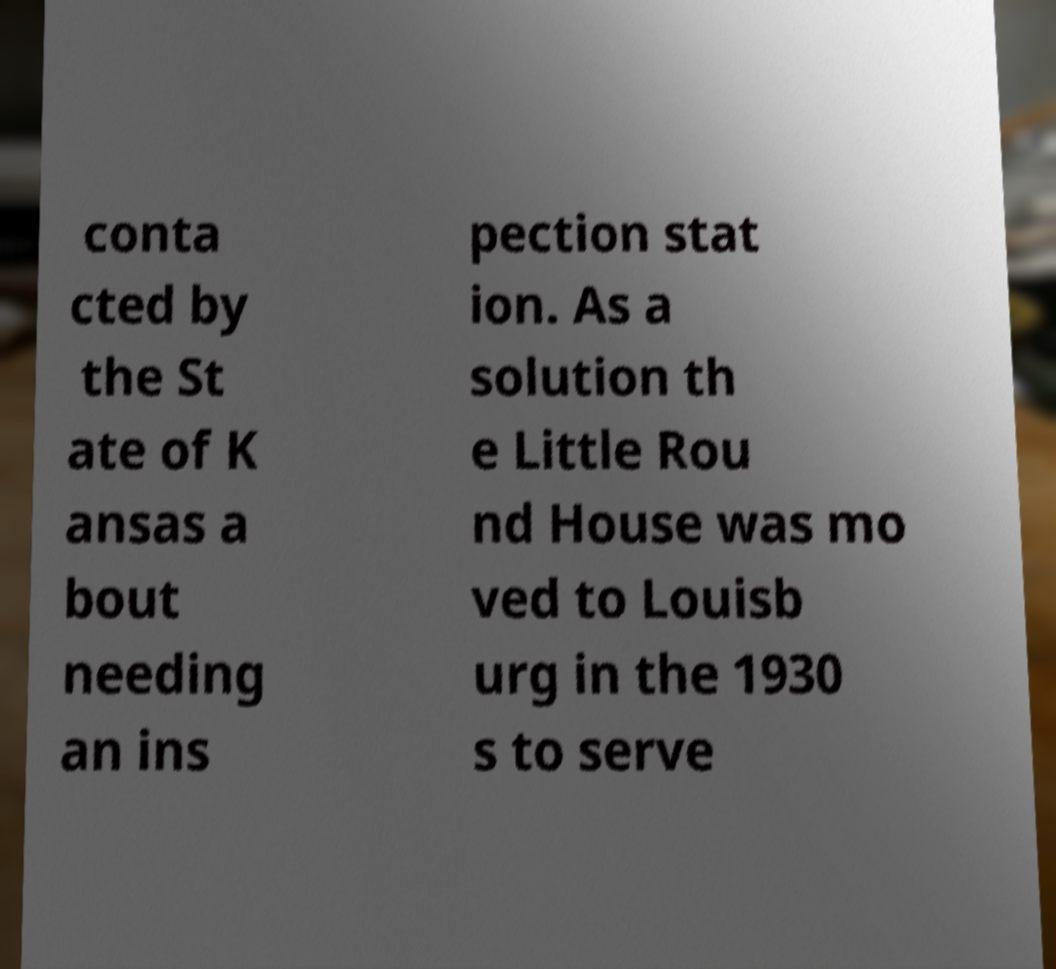Can you accurately transcribe the text from the provided image for me? conta cted by the St ate of K ansas a bout needing an ins pection stat ion. As a solution th e Little Rou nd House was mo ved to Louisb urg in the 1930 s to serve 